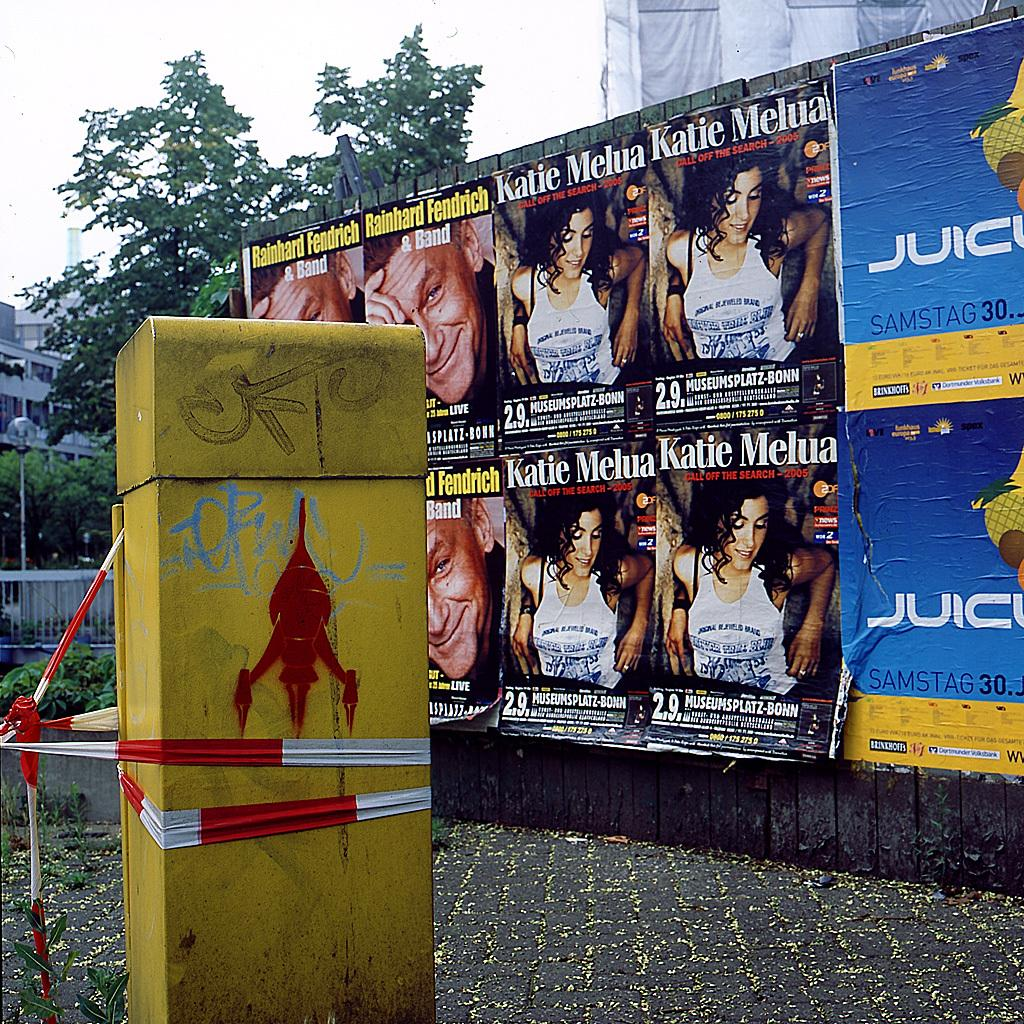<image>
Render a clear and concise summary of the photo. a few posters of a woman named katie are on a wall outside 